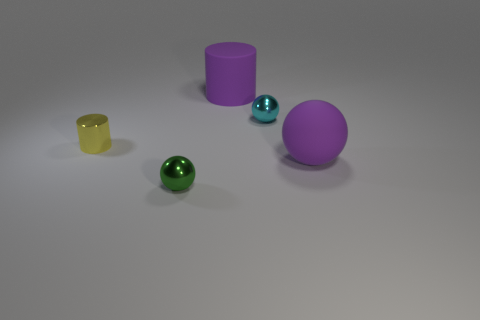Add 5 red rubber cylinders. How many objects exist? 10 Subtract all cylinders. How many objects are left? 3 Add 1 balls. How many balls are left? 4 Add 4 yellow shiny cylinders. How many yellow shiny cylinders exist? 5 Subtract 0 yellow spheres. How many objects are left? 5 Subtract all tiny cyan metallic balls. Subtract all rubber cylinders. How many objects are left? 3 